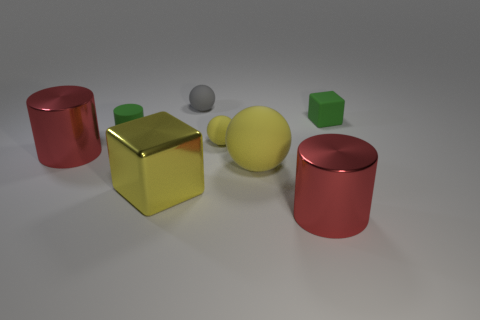What shape is the big thing that is both behind the large metal block and to the right of the yellow cube?
Ensure brevity in your answer.  Sphere. Is there a large yellow thing made of the same material as the small green block?
Your answer should be compact. Yes. There is a large object that is the same color as the large shiny block; what is it made of?
Offer a terse response. Rubber. Does the sphere that is on the right side of the small yellow thing have the same material as the cylinder that is right of the small yellow rubber sphere?
Make the answer very short. No. Are there more large metal cylinders than large brown matte balls?
Your answer should be compact. Yes. There is a large shiny thing that is to the right of the yellow matte thing behind the red cylinder on the left side of the small gray thing; what color is it?
Provide a short and direct response. Red. There is a cube that is behind the tiny yellow object; does it have the same color as the cube that is in front of the tiny cylinder?
Your answer should be very brief. No. How many yellow balls are right of the small matte ball in front of the green block?
Your answer should be very brief. 1. Is there a tiny gray ball?
Your response must be concise. Yes. How many other objects are there of the same color as the small cylinder?
Your response must be concise. 1. 